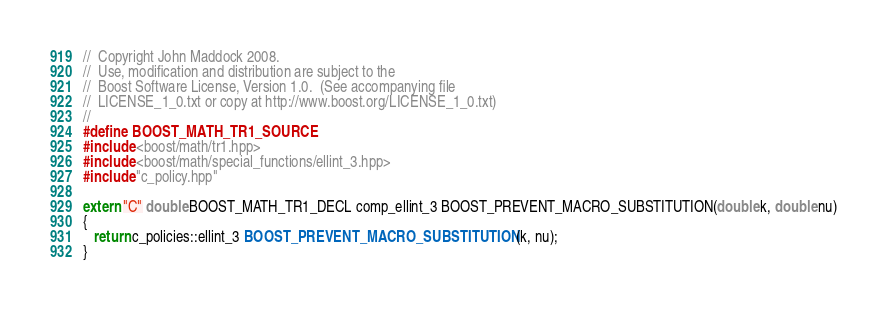<code> <loc_0><loc_0><loc_500><loc_500><_C++_>//  Copyright John Maddock 2008.
//  Use, modification and distribution are subject to the
//  Boost Software License, Version 1.0.  (See accompanying file
//  LICENSE_1_0.txt or copy at http://www.boost.org/LICENSE_1_0.txt)
//
#define BOOST_MATH_TR1_SOURCE
#include <boost/math/tr1.hpp>
#include <boost/math/special_functions/ellint_3.hpp>
#include "c_policy.hpp"

extern "C" double BOOST_MATH_TR1_DECL comp_ellint_3 BOOST_PREVENT_MACRO_SUBSTITUTION(double k, double nu)
{
   return c_policies::ellint_3 BOOST_PREVENT_MACRO_SUBSTITUTION(k, nu);
}
</code> 